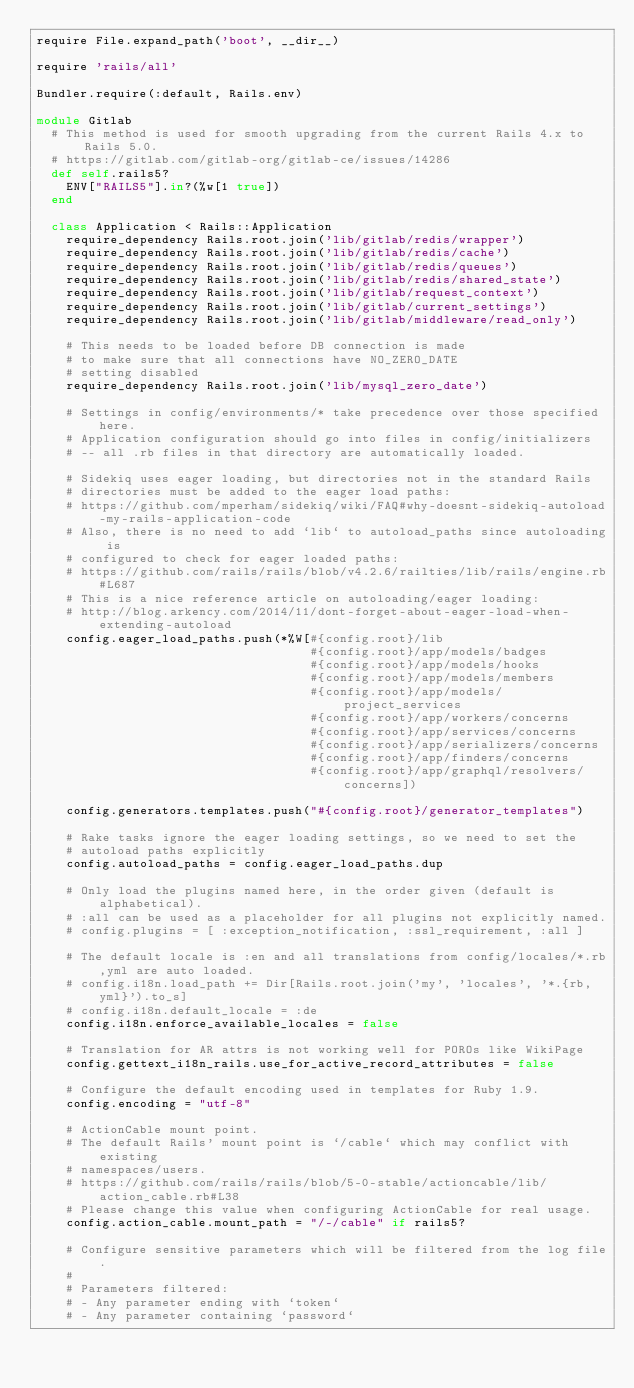Convert code to text. <code><loc_0><loc_0><loc_500><loc_500><_Ruby_>require File.expand_path('boot', __dir__)

require 'rails/all'

Bundler.require(:default, Rails.env)

module Gitlab
  # This method is used for smooth upgrading from the current Rails 4.x to Rails 5.0.
  # https://gitlab.com/gitlab-org/gitlab-ce/issues/14286
  def self.rails5?
    ENV["RAILS5"].in?(%w[1 true])
  end

  class Application < Rails::Application
    require_dependency Rails.root.join('lib/gitlab/redis/wrapper')
    require_dependency Rails.root.join('lib/gitlab/redis/cache')
    require_dependency Rails.root.join('lib/gitlab/redis/queues')
    require_dependency Rails.root.join('lib/gitlab/redis/shared_state')
    require_dependency Rails.root.join('lib/gitlab/request_context')
    require_dependency Rails.root.join('lib/gitlab/current_settings')
    require_dependency Rails.root.join('lib/gitlab/middleware/read_only')

    # This needs to be loaded before DB connection is made
    # to make sure that all connections have NO_ZERO_DATE
    # setting disabled
    require_dependency Rails.root.join('lib/mysql_zero_date')

    # Settings in config/environments/* take precedence over those specified here.
    # Application configuration should go into files in config/initializers
    # -- all .rb files in that directory are automatically loaded.

    # Sidekiq uses eager loading, but directories not in the standard Rails
    # directories must be added to the eager load paths:
    # https://github.com/mperham/sidekiq/wiki/FAQ#why-doesnt-sidekiq-autoload-my-rails-application-code
    # Also, there is no need to add `lib` to autoload_paths since autoloading is
    # configured to check for eager loaded paths:
    # https://github.com/rails/rails/blob/v4.2.6/railties/lib/rails/engine.rb#L687
    # This is a nice reference article on autoloading/eager loading:
    # http://blog.arkency.com/2014/11/dont-forget-about-eager-load-when-extending-autoload
    config.eager_load_paths.push(*%W[#{config.root}/lib
                                     #{config.root}/app/models/badges
                                     #{config.root}/app/models/hooks
                                     #{config.root}/app/models/members
                                     #{config.root}/app/models/project_services
                                     #{config.root}/app/workers/concerns
                                     #{config.root}/app/services/concerns
                                     #{config.root}/app/serializers/concerns
                                     #{config.root}/app/finders/concerns
                                     #{config.root}/app/graphql/resolvers/concerns])

    config.generators.templates.push("#{config.root}/generator_templates")

    # Rake tasks ignore the eager loading settings, so we need to set the
    # autoload paths explicitly
    config.autoload_paths = config.eager_load_paths.dup

    # Only load the plugins named here, in the order given (default is alphabetical).
    # :all can be used as a placeholder for all plugins not explicitly named.
    # config.plugins = [ :exception_notification, :ssl_requirement, :all ]

    # The default locale is :en and all translations from config/locales/*.rb,yml are auto loaded.
    # config.i18n.load_path += Dir[Rails.root.join('my', 'locales', '*.{rb,yml}').to_s]
    # config.i18n.default_locale = :de
    config.i18n.enforce_available_locales = false

    # Translation for AR attrs is not working well for POROs like WikiPage
    config.gettext_i18n_rails.use_for_active_record_attributes = false

    # Configure the default encoding used in templates for Ruby 1.9.
    config.encoding = "utf-8"

    # ActionCable mount point.
    # The default Rails' mount point is `/cable` which may conflict with existing
    # namespaces/users.
    # https://github.com/rails/rails/blob/5-0-stable/actioncable/lib/action_cable.rb#L38
    # Please change this value when configuring ActionCable for real usage.
    config.action_cable.mount_path = "/-/cable" if rails5?

    # Configure sensitive parameters which will be filtered from the log file.
    #
    # Parameters filtered:
    # - Any parameter ending with `token`
    # - Any parameter containing `password`</code> 